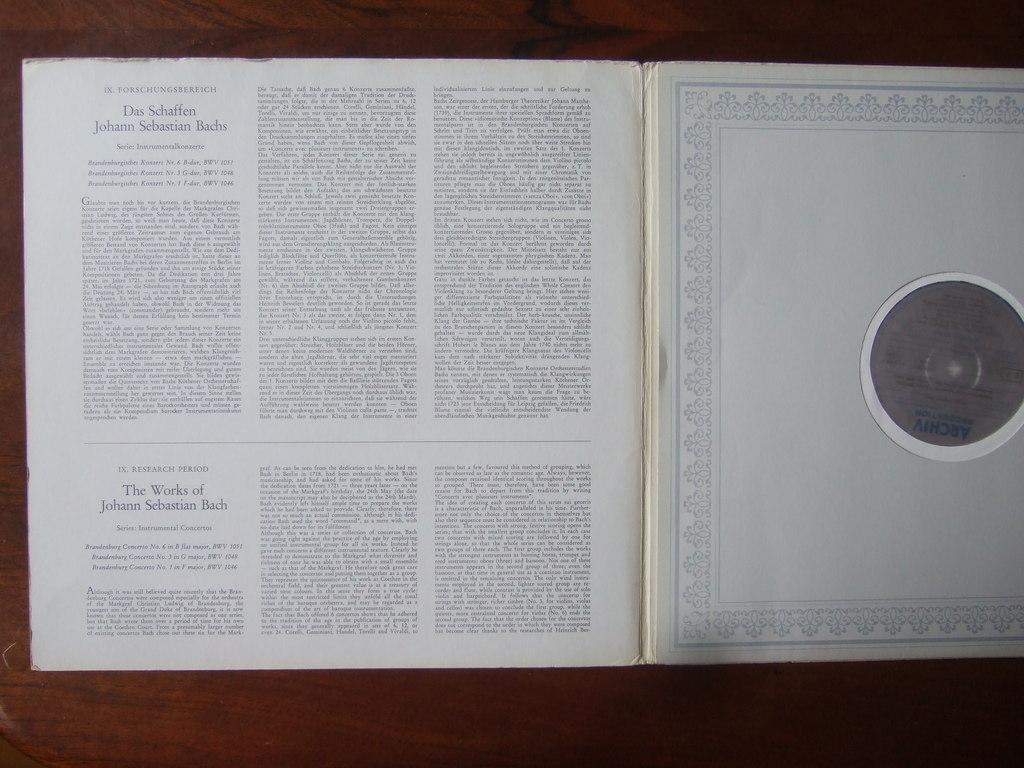Provide a one-sentence caption for the provided image. A book that is about the musical works of Bach. 